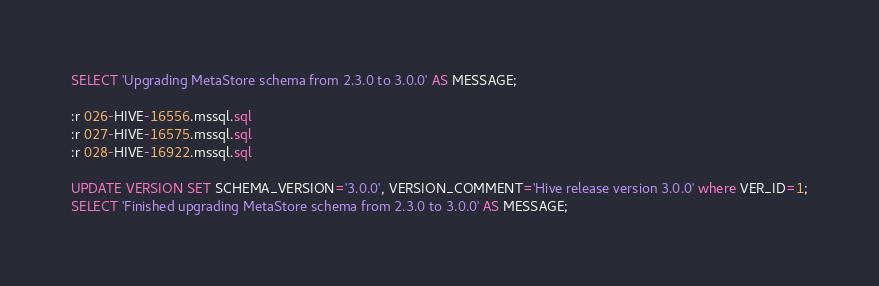<code> <loc_0><loc_0><loc_500><loc_500><_SQL_>SELECT 'Upgrading MetaStore schema from 2.3.0 to 3.0.0' AS MESSAGE;

:r 026-HIVE-16556.mssql.sql
:r 027-HIVE-16575.mssql.sql
:r 028-HIVE-16922.mssql.sql

UPDATE VERSION SET SCHEMA_VERSION='3.0.0', VERSION_COMMENT='Hive release version 3.0.0' where VER_ID=1;
SELECT 'Finished upgrading MetaStore schema from 2.3.0 to 3.0.0' AS MESSAGE;
</code> 